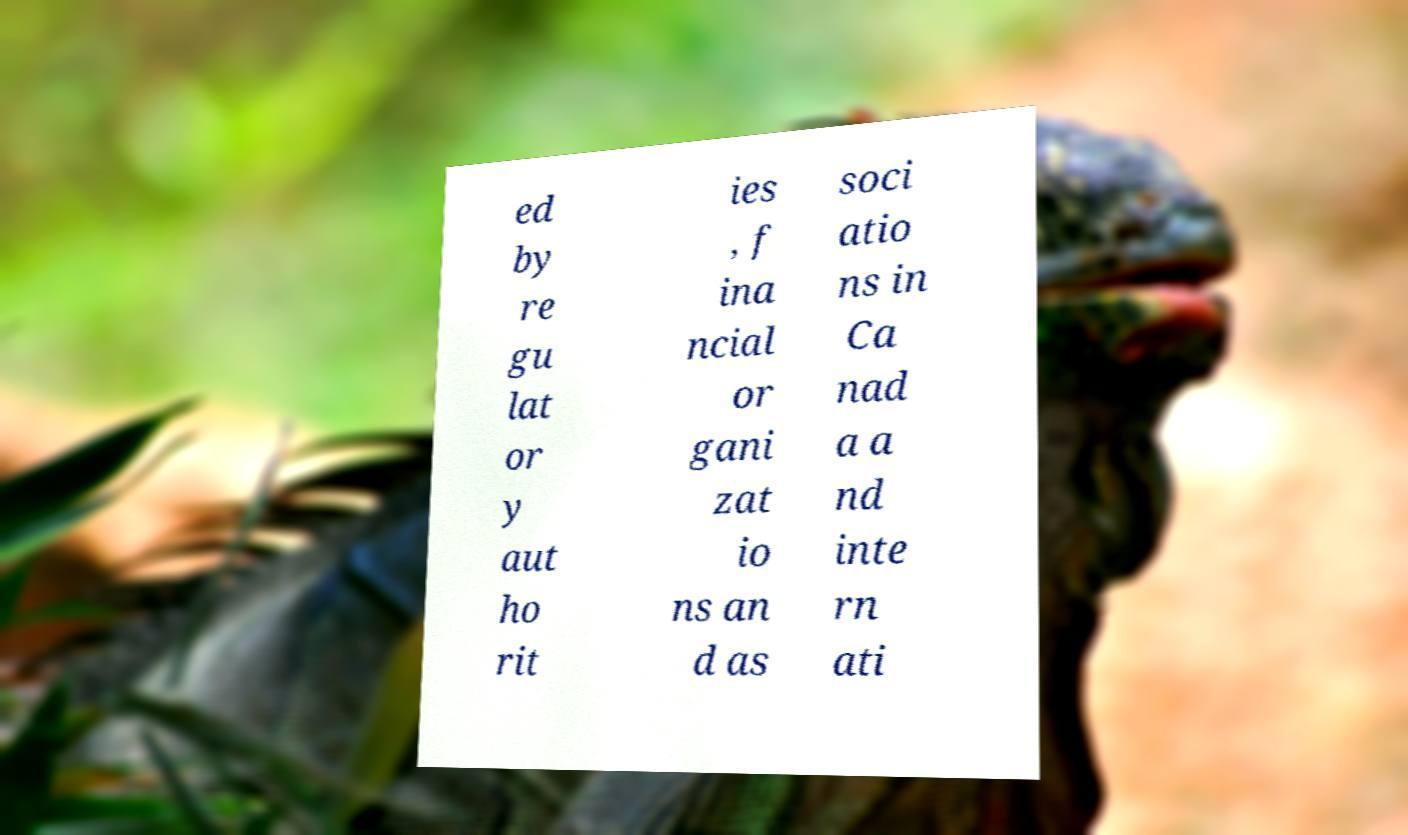Could you extract and type out the text from this image? ed by re gu lat or y aut ho rit ies , f ina ncial or gani zat io ns an d as soci atio ns in Ca nad a a nd inte rn ati 